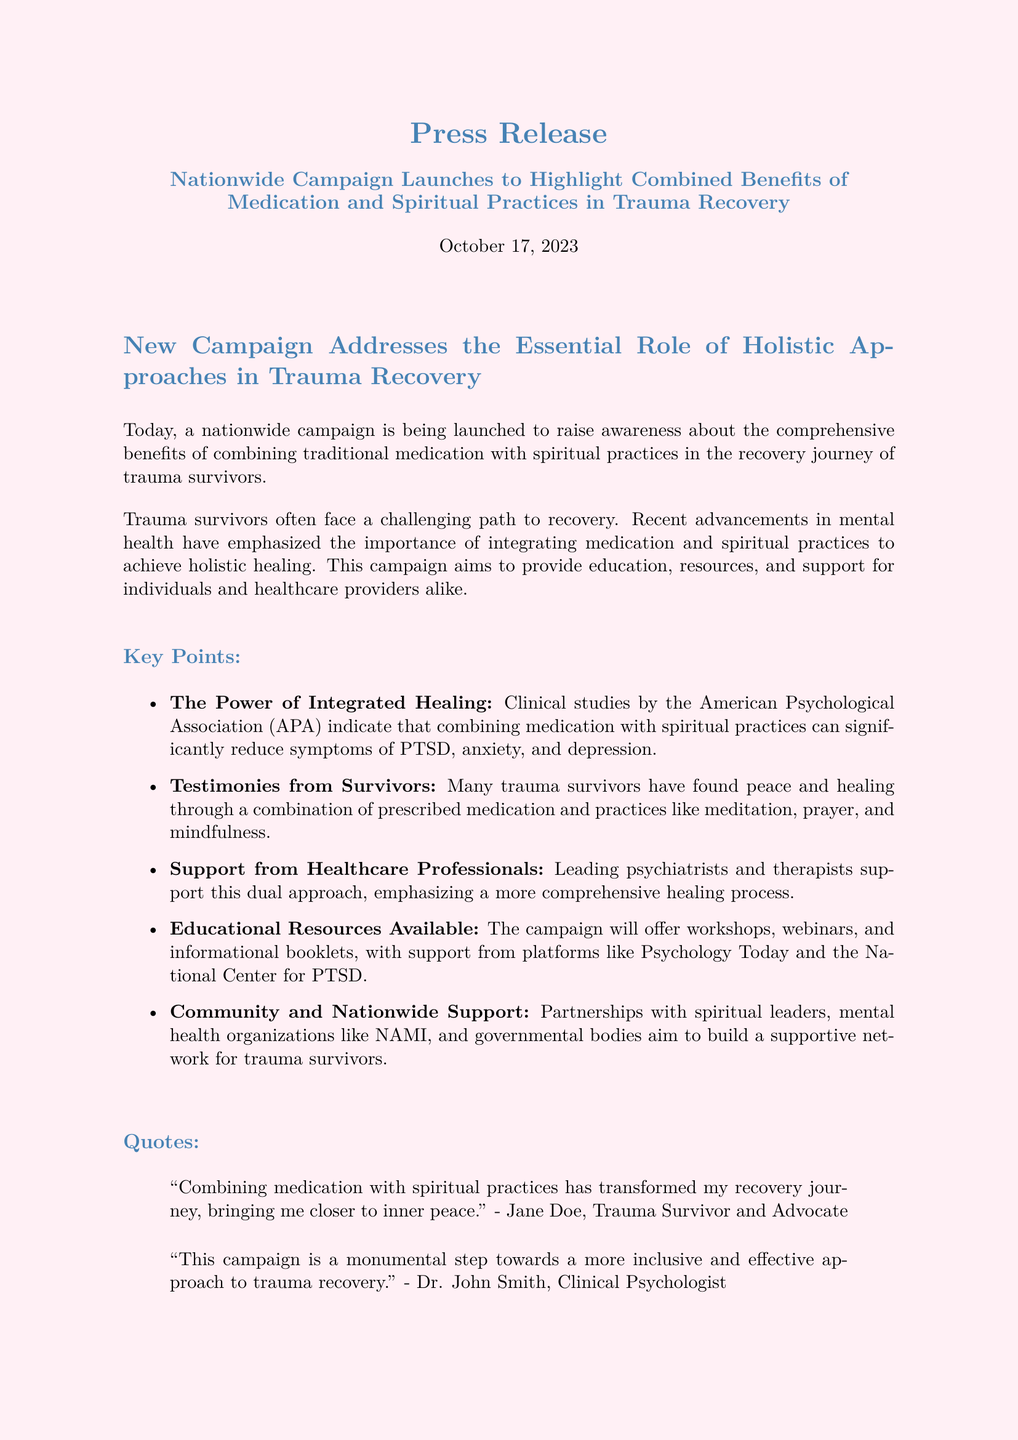What is the launch date of the campaign? The launch date of the campaign is mentioned at the beginning of the document as October 17, 2023.
Answer: October 17, 2023 What organization conducted studies supporting the campaign? The studies supporting the campaign were conducted by the American Psychological Association (APA).
Answer: American Psychological Association What mental health issues does the campaign aim to address? The campaign aims to address PTSD, anxiety, and depression, as mentioned in the key points section.
Answer: PTSD, anxiety, and depression Who is quoted as a trauma survivor and advocate? The document cites Jane Doe as a trauma survivor and advocate in a quote.
Answer: Jane Doe What types of resources will the campaign provide? The campaign will offer workshops, webinars, and informational booklets as highlighted in the educational resources section.
Answer: Workshops, webinars, and informational booklets Why do healthcare professionals support the dual approach? Healthcare professionals support the dual approach because it emphasizes a more comprehensive healing process, as mentioned in the key points.
Answer: Comprehensive healing process What is the website for the campaign? The campaign's website is provided in the call to action section as www.holistichealingcampaign.org.
Answer: www.holistichealingcampaign.org What is the primary goal of the campaign? The primary goal of the campaign is to raise awareness about the benefits of combining medication and spiritual practices in trauma recovery.
Answer: Raise awareness about the benefits of combining medication and spiritual practices 